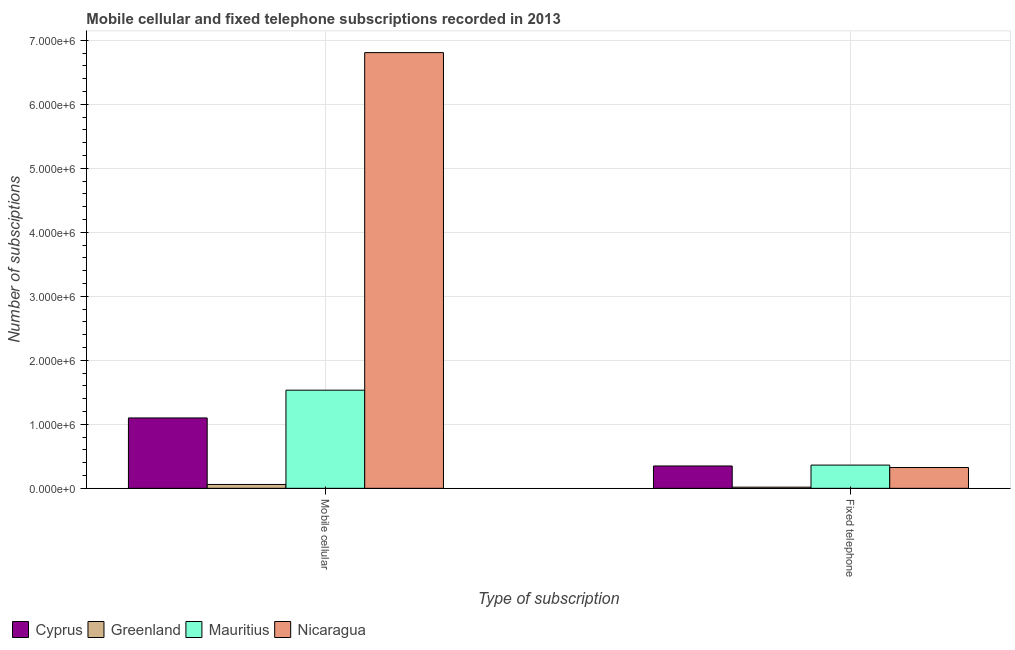How many different coloured bars are there?
Offer a very short reply. 4. Are the number of bars per tick equal to the number of legend labels?
Offer a very short reply. Yes. How many bars are there on the 1st tick from the left?
Provide a short and direct response. 4. How many bars are there on the 1st tick from the right?
Provide a short and direct response. 4. What is the label of the 1st group of bars from the left?
Your answer should be compact. Mobile cellular. What is the number of mobile cellular subscriptions in Nicaragua?
Make the answer very short. 6.81e+06. Across all countries, what is the maximum number of fixed telephone subscriptions?
Your response must be concise. 3.63e+05. Across all countries, what is the minimum number of mobile cellular subscriptions?
Your answer should be very brief. 6.04e+04. In which country was the number of mobile cellular subscriptions maximum?
Provide a short and direct response. Nicaragua. In which country was the number of mobile cellular subscriptions minimum?
Keep it short and to the point. Greenland. What is the total number of fixed telephone subscriptions in the graph?
Make the answer very short. 1.06e+06. What is the difference between the number of mobile cellular subscriptions in Mauritius and that in Nicaragua?
Provide a short and direct response. -5.28e+06. What is the difference between the number of mobile cellular subscriptions in Nicaragua and the number of fixed telephone subscriptions in Cyprus?
Offer a very short reply. 6.46e+06. What is the average number of fixed telephone subscriptions per country?
Make the answer very short. 2.64e+05. What is the difference between the number of fixed telephone subscriptions and number of mobile cellular subscriptions in Mauritius?
Your answer should be very brief. -1.17e+06. In how many countries, is the number of mobile cellular subscriptions greater than 3000000 ?
Provide a short and direct response. 1. What is the ratio of the number of mobile cellular subscriptions in Cyprus to that in Mauritius?
Your answer should be compact. 0.72. What does the 3rd bar from the left in Mobile cellular represents?
Provide a succinct answer. Mauritius. What does the 4th bar from the right in Fixed telephone represents?
Your answer should be compact. Cyprus. Are all the bars in the graph horizontal?
Make the answer very short. No. Does the graph contain any zero values?
Provide a short and direct response. No. How are the legend labels stacked?
Ensure brevity in your answer.  Horizontal. What is the title of the graph?
Offer a terse response. Mobile cellular and fixed telephone subscriptions recorded in 2013. What is the label or title of the X-axis?
Your response must be concise. Type of subscription. What is the label or title of the Y-axis?
Offer a very short reply. Number of subsciptions. What is the Number of subsciptions of Cyprus in Mobile cellular?
Your answer should be very brief. 1.10e+06. What is the Number of subsciptions of Greenland in Mobile cellular?
Keep it short and to the point. 6.04e+04. What is the Number of subsciptions of Mauritius in Mobile cellular?
Give a very brief answer. 1.53e+06. What is the Number of subsciptions in Nicaragua in Mobile cellular?
Offer a terse response. 6.81e+06. What is the Number of subsciptions in Cyprus in Fixed telephone?
Offer a terse response. 3.49e+05. What is the Number of subsciptions in Greenland in Fixed telephone?
Your response must be concise. 1.80e+04. What is the Number of subsciptions of Mauritius in Fixed telephone?
Your response must be concise. 3.63e+05. What is the Number of subsciptions in Nicaragua in Fixed telephone?
Give a very brief answer. 3.25e+05. Across all Type of subscription, what is the maximum Number of subsciptions of Cyprus?
Your response must be concise. 1.10e+06. Across all Type of subscription, what is the maximum Number of subsciptions in Greenland?
Provide a short and direct response. 6.04e+04. Across all Type of subscription, what is the maximum Number of subsciptions in Mauritius?
Offer a very short reply. 1.53e+06. Across all Type of subscription, what is the maximum Number of subsciptions of Nicaragua?
Keep it short and to the point. 6.81e+06. Across all Type of subscription, what is the minimum Number of subsciptions in Cyprus?
Make the answer very short. 3.49e+05. Across all Type of subscription, what is the minimum Number of subsciptions of Greenland?
Offer a terse response. 1.80e+04. Across all Type of subscription, what is the minimum Number of subsciptions in Mauritius?
Provide a short and direct response. 3.63e+05. Across all Type of subscription, what is the minimum Number of subsciptions in Nicaragua?
Keep it short and to the point. 3.25e+05. What is the total Number of subsciptions in Cyprus in the graph?
Make the answer very short. 1.45e+06. What is the total Number of subsciptions in Greenland in the graph?
Give a very brief answer. 7.84e+04. What is the total Number of subsciptions of Mauritius in the graph?
Your response must be concise. 1.90e+06. What is the total Number of subsciptions of Nicaragua in the graph?
Offer a terse response. 7.13e+06. What is the difference between the Number of subsciptions of Cyprus in Mobile cellular and that in Fixed telephone?
Your answer should be compact. 7.51e+05. What is the difference between the Number of subsciptions of Greenland in Mobile cellular and that in Fixed telephone?
Keep it short and to the point. 4.24e+04. What is the difference between the Number of subsciptions in Mauritius in Mobile cellular and that in Fixed telephone?
Offer a terse response. 1.17e+06. What is the difference between the Number of subsciptions in Nicaragua in Mobile cellular and that in Fixed telephone?
Provide a short and direct response. 6.48e+06. What is the difference between the Number of subsciptions in Cyprus in Mobile cellular and the Number of subsciptions in Greenland in Fixed telephone?
Your answer should be very brief. 1.08e+06. What is the difference between the Number of subsciptions of Cyprus in Mobile cellular and the Number of subsciptions of Mauritius in Fixed telephone?
Your response must be concise. 7.37e+05. What is the difference between the Number of subsciptions of Cyprus in Mobile cellular and the Number of subsciptions of Nicaragua in Fixed telephone?
Keep it short and to the point. 7.75e+05. What is the difference between the Number of subsciptions of Greenland in Mobile cellular and the Number of subsciptions of Mauritius in Fixed telephone?
Provide a short and direct response. -3.03e+05. What is the difference between the Number of subsciptions of Greenland in Mobile cellular and the Number of subsciptions of Nicaragua in Fixed telephone?
Provide a succinct answer. -2.65e+05. What is the difference between the Number of subsciptions of Mauritius in Mobile cellular and the Number of subsciptions of Nicaragua in Fixed telephone?
Offer a very short reply. 1.21e+06. What is the average Number of subsciptions in Cyprus per Type of subscription?
Your response must be concise. 7.24e+05. What is the average Number of subsciptions of Greenland per Type of subscription?
Your response must be concise. 3.92e+04. What is the average Number of subsciptions of Mauritius per Type of subscription?
Provide a short and direct response. 9.48e+05. What is the average Number of subsciptions of Nicaragua per Type of subscription?
Offer a terse response. 3.57e+06. What is the difference between the Number of subsciptions of Cyprus and Number of subsciptions of Greenland in Mobile cellular?
Give a very brief answer. 1.04e+06. What is the difference between the Number of subsciptions in Cyprus and Number of subsciptions in Mauritius in Mobile cellular?
Offer a terse response. -4.34e+05. What is the difference between the Number of subsciptions in Cyprus and Number of subsciptions in Nicaragua in Mobile cellular?
Make the answer very short. -5.71e+06. What is the difference between the Number of subsciptions of Greenland and Number of subsciptions of Mauritius in Mobile cellular?
Provide a succinct answer. -1.47e+06. What is the difference between the Number of subsciptions in Greenland and Number of subsciptions in Nicaragua in Mobile cellular?
Give a very brief answer. -6.75e+06. What is the difference between the Number of subsciptions in Mauritius and Number of subsciptions in Nicaragua in Mobile cellular?
Offer a terse response. -5.28e+06. What is the difference between the Number of subsciptions of Cyprus and Number of subsciptions of Greenland in Fixed telephone?
Ensure brevity in your answer.  3.31e+05. What is the difference between the Number of subsciptions of Cyprus and Number of subsciptions of Mauritius in Fixed telephone?
Give a very brief answer. -1.39e+04. What is the difference between the Number of subsciptions in Cyprus and Number of subsciptions in Nicaragua in Fixed telephone?
Your answer should be compact. 2.41e+04. What is the difference between the Number of subsciptions in Greenland and Number of subsciptions in Mauritius in Fixed telephone?
Your response must be concise. -3.45e+05. What is the difference between the Number of subsciptions in Greenland and Number of subsciptions in Nicaragua in Fixed telephone?
Make the answer very short. -3.07e+05. What is the difference between the Number of subsciptions of Mauritius and Number of subsciptions of Nicaragua in Fixed telephone?
Ensure brevity in your answer.  3.80e+04. What is the ratio of the Number of subsciptions in Cyprus in Mobile cellular to that in Fixed telephone?
Provide a short and direct response. 3.15. What is the ratio of the Number of subsciptions of Greenland in Mobile cellular to that in Fixed telephone?
Make the answer very short. 3.36. What is the ratio of the Number of subsciptions of Mauritius in Mobile cellular to that in Fixed telephone?
Your answer should be very brief. 4.22. What is the ratio of the Number of subsciptions in Nicaragua in Mobile cellular to that in Fixed telephone?
Give a very brief answer. 20.95. What is the difference between the highest and the second highest Number of subsciptions in Cyprus?
Your response must be concise. 7.51e+05. What is the difference between the highest and the second highest Number of subsciptions in Greenland?
Provide a succinct answer. 4.24e+04. What is the difference between the highest and the second highest Number of subsciptions in Mauritius?
Ensure brevity in your answer.  1.17e+06. What is the difference between the highest and the second highest Number of subsciptions of Nicaragua?
Make the answer very short. 6.48e+06. What is the difference between the highest and the lowest Number of subsciptions in Cyprus?
Your answer should be compact. 7.51e+05. What is the difference between the highest and the lowest Number of subsciptions in Greenland?
Offer a very short reply. 4.24e+04. What is the difference between the highest and the lowest Number of subsciptions of Mauritius?
Ensure brevity in your answer.  1.17e+06. What is the difference between the highest and the lowest Number of subsciptions in Nicaragua?
Your response must be concise. 6.48e+06. 